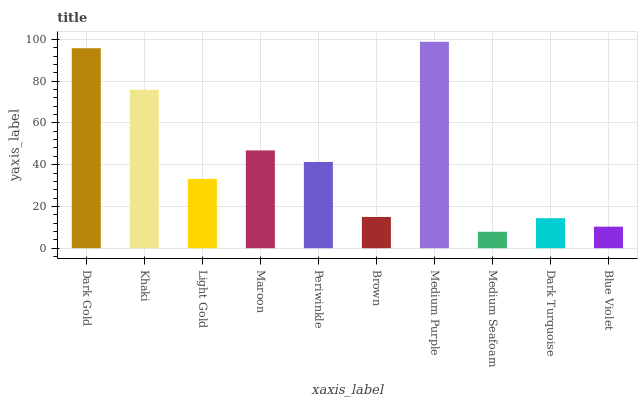Is Medium Seafoam the minimum?
Answer yes or no. Yes. Is Medium Purple the maximum?
Answer yes or no. Yes. Is Khaki the minimum?
Answer yes or no. No. Is Khaki the maximum?
Answer yes or no. No. Is Dark Gold greater than Khaki?
Answer yes or no. Yes. Is Khaki less than Dark Gold?
Answer yes or no. Yes. Is Khaki greater than Dark Gold?
Answer yes or no. No. Is Dark Gold less than Khaki?
Answer yes or no. No. Is Periwinkle the high median?
Answer yes or no. Yes. Is Light Gold the low median?
Answer yes or no. Yes. Is Blue Violet the high median?
Answer yes or no. No. Is Dark Turquoise the low median?
Answer yes or no. No. 